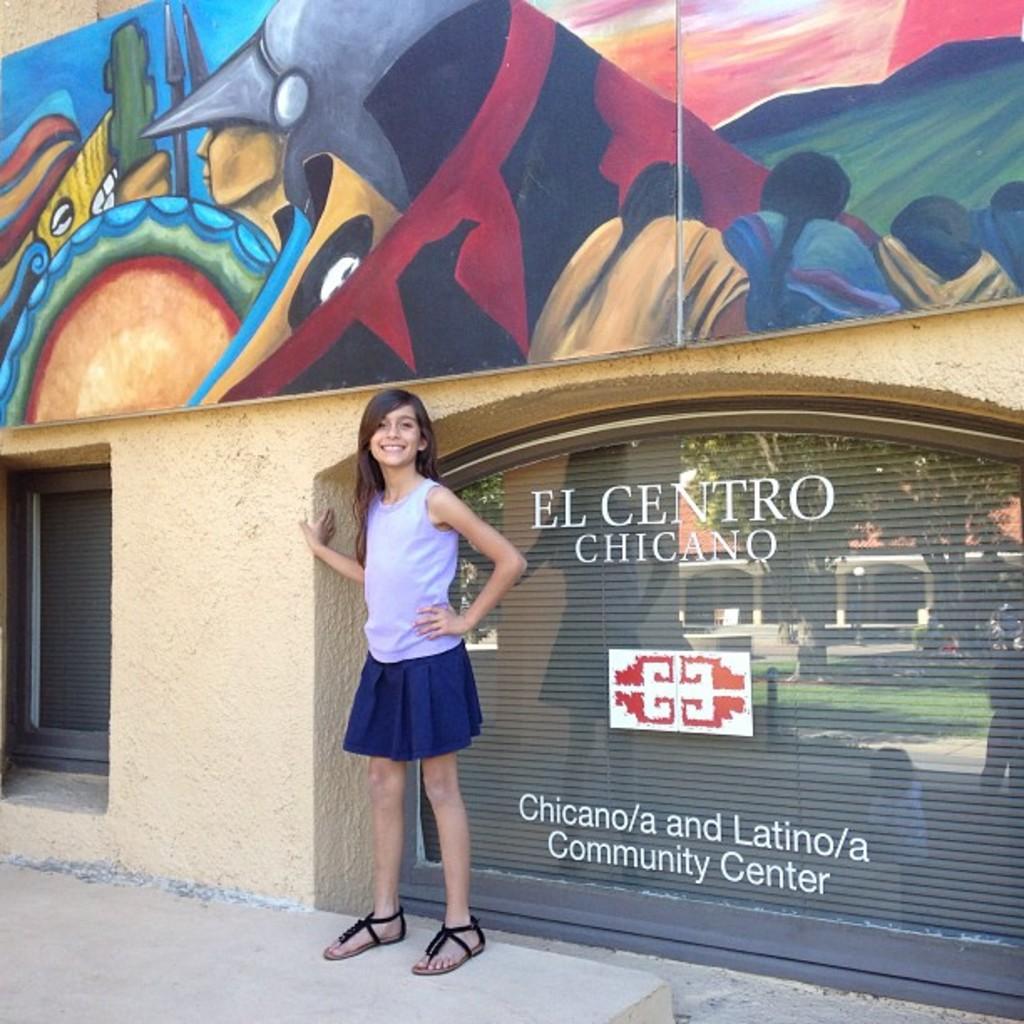Where is that at?
Your answer should be very brief. El centro chicano. What type of building is this?
Your answer should be compact. Community center. 